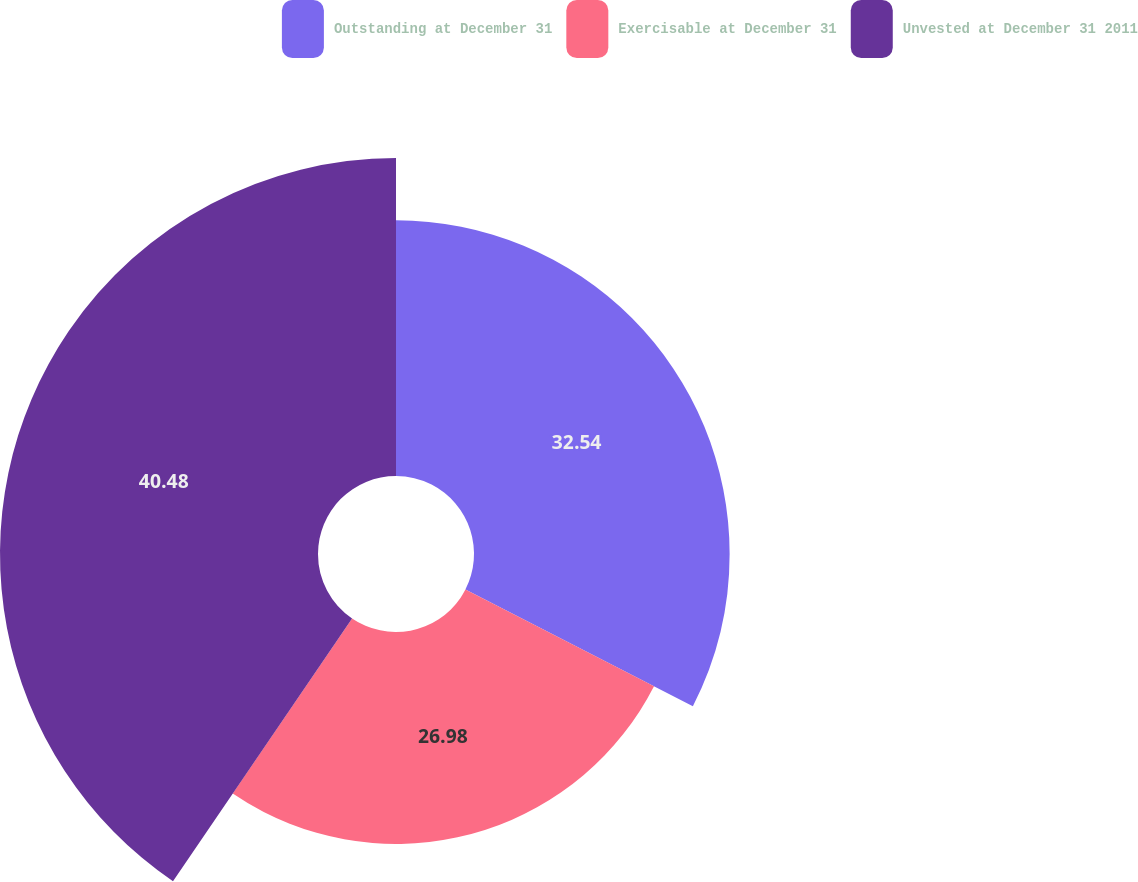<chart> <loc_0><loc_0><loc_500><loc_500><pie_chart><fcel>Outstanding at December 31<fcel>Exercisable at December 31<fcel>Unvested at December 31 2011<nl><fcel>32.54%<fcel>26.98%<fcel>40.48%<nl></chart> 